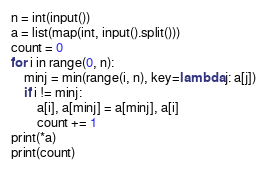<code> <loc_0><loc_0><loc_500><loc_500><_Python_>n = int(input())
a = list(map(int, input().split()))
count = 0
for i in range(0, n):
	minj = min(range(i, n), key=lambda j: a[j])
	if i != minj:
		a[i], a[minj] = a[minj], a[i]
		count += 1
print(*a)
print(count)
</code> 